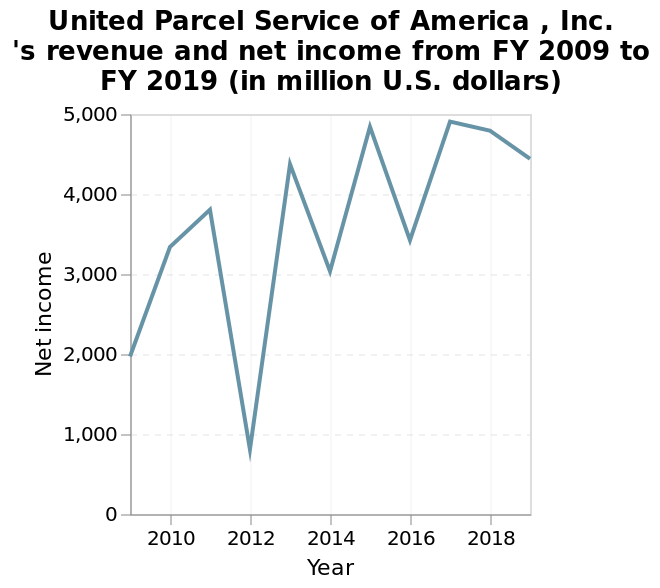<image>
Offer a thorough analysis of the image. There is a dip on every even numbered year (2012, 2014, 2016) and 2012 has by far the biggest dip. In which years did the net income of United Parcel Service (UPS) have ups and downs?  The net income of United Parcel Service (UPS) had ups and downs in the years 2012, 2014, and 2015. What was the net income of United Parcel Service (UPS) in 2009?  The net income of United Parcel Service (UPS) in 2009 was 2000. What type of scale is used for the x-axis in the line graph? The x-axis of the line graph uses a linear scale. Did the net income of United Parcel Service (UPS) have ups and downs in the years 2012, 2013, and 2015? No. The net income of United Parcel Service (UPS) had ups and downs in the years 2012, 2014, and 2015. 